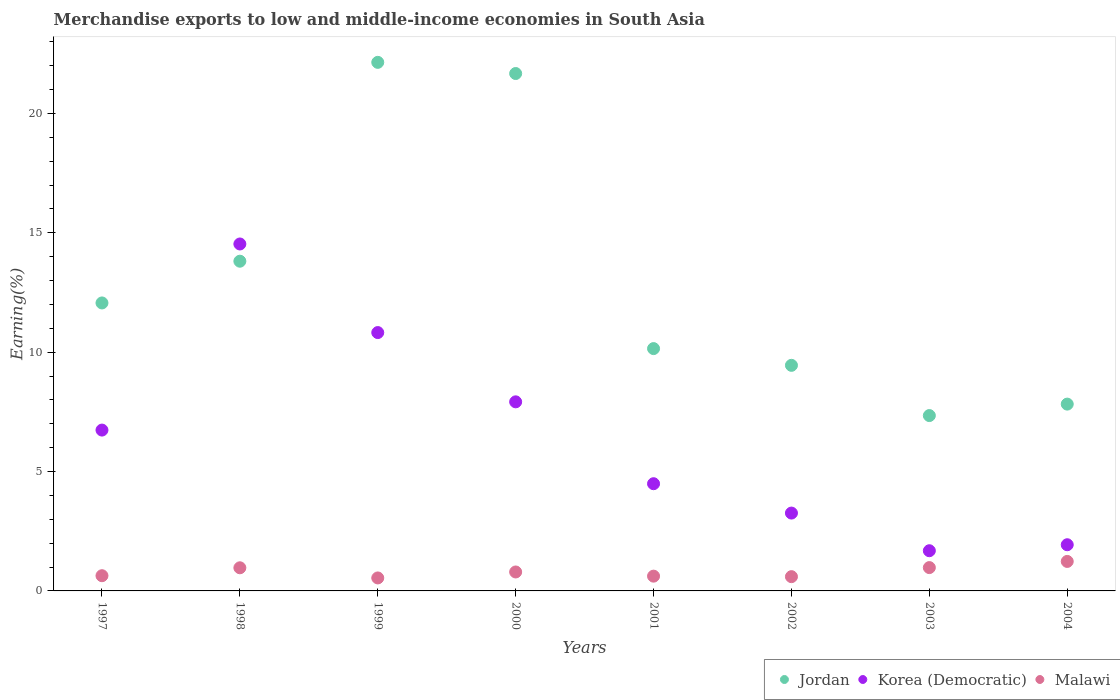How many different coloured dotlines are there?
Offer a terse response. 3. Is the number of dotlines equal to the number of legend labels?
Provide a succinct answer. Yes. What is the percentage of amount earned from merchandise exports in Korea (Democratic) in 1998?
Make the answer very short. 14.53. Across all years, what is the maximum percentage of amount earned from merchandise exports in Jordan?
Give a very brief answer. 22.14. Across all years, what is the minimum percentage of amount earned from merchandise exports in Korea (Democratic)?
Your answer should be very brief. 1.68. In which year was the percentage of amount earned from merchandise exports in Jordan maximum?
Make the answer very short. 1999. What is the total percentage of amount earned from merchandise exports in Malawi in the graph?
Your answer should be very brief. 6.37. What is the difference between the percentage of amount earned from merchandise exports in Jordan in 1999 and that in 2004?
Offer a very short reply. 14.31. What is the difference between the percentage of amount earned from merchandise exports in Korea (Democratic) in 2002 and the percentage of amount earned from merchandise exports in Jordan in 1999?
Your answer should be very brief. -18.88. What is the average percentage of amount earned from merchandise exports in Malawi per year?
Make the answer very short. 0.8. In the year 2004, what is the difference between the percentage of amount earned from merchandise exports in Korea (Democratic) and percentage of amount earned from merchandise exports in Jordan?
Keep it short and to the point. -5.89. In how many years, is the percentage of amount earned from merchandise exports in Korea (Democratic) greater than 9 %?
Your answer should be compact. 2. What is the ratio of the percentage of amount earned from merchandise exports in Jordan in 2002 to that in 2003?
Ensure brevity in your answer.  1.29. Is the percentage of amount earned from merchandise exports in Korea (Democratic) in 1999 less than that in 2002?
Your answer should be very brief. No. What is the difference between the highest and the second highest percentage of amount earned from merchandise exports in Jordan?
Your response must be concise. 0.47. What is the difference between the highest and the lowest percentage of amount earned from merchandise exports in Jordan?
Offer a terse response. 14.79. In how many years, is the percentage of amount earned from merchandise exports in Malawi greater than the average percentage of amount earned from merchandise exports in Malawi taken over all years?
Provide a succinct answer. 3. Does the percentage of amount earned from merchandise exports in Korea (Democratic) monotonically increase over the years?
Your answer should be very brief. No. Is the percentage of amount earned from merchandise exports in Jordan strictly less than the percentage of amount earned from merchandise exports in Korea (Democratic) over the years?
Your response must be concise. No. How many dotlines are there?
Keep it short and to the point. 3. What is the difference between two consecutive major ticks on the Y-axis?
Provide a succinct answer. 5. Are the values on the major ticks of Y-axis written in scientific E-notation?
Ensure brevity in your answer.  No. Where does the legend appear in the graph?
Your response must be concise. Bottom right. What is the title of the graph?
Your answer should be compact. Merchandise exports to low and middle-income economies in South Asia. What is the label or title of the Y-axis?
Your response must be concise. Earning(%). What is the Earning(%) of Jordan in 1997?
Offer a terse response. 12.06. What is the Earning(%) of Korea (Democratic) in 1997?
Give a very brief answer. 6.74. What is the Earning(%) of Malawi in 1997?
Offer a terse response. 0.64. What is the Earning(%) of Jordan in 1998?
Your answer should be very brief. 13.81. What is the Earning(%) of Korea (Democratic) in 1998?
Ensure brevity in your answer.  14.53. What is the Earning(%) of Malawi in 1998?
Provide a short and direct response. 0.97. What is the Earning(%) in Jordan in 1999?
Offer a terse response. 22.14. What is the Earning(%) of Korea (Democratic) in 1999?
Provide a succinct answer. 10.82. What is the Earning(%) in Malawi in 1999?
Give a very brief answer. 0.54. What is the Earning(%) in Jordan in 2000?
Provide a succinct answer. 21.67. What is the Earning(%) of Korea (Democratic) in 2000?
Provide a short and direct response. 7.92. What is the Earning(%) in Malawi in 2000?
Offer a very short reply. 0.79. What is the Earning(%) of Jordan in 2001?
Offer a very short reply. 10.15. What is the Earning(%) of Korea (Democratic) in 2001?
Ensure brevity in your answer.  4.49. What is the Earning(%) in Malawi in 2001?
Your answer should be compact. 0.62. What is the Earning(%) in Jordan in 2002?
Ensure brevity in your answer.  9.45. What is the Earning(%) in Korea (Democratic) in 2002?
Ensure brevity in your answer.  3.26. What is the Earning(%) of Malawi in 2002?
Offer a terse response. 0.6. What is the Earning(%) of Jordan in 2003?
Provide a short and direct response. 7.34. What is the Earning(%) of Korea (Democratic) in 2003?
Your response must be concise. 1.68. What is the Earning(%) of Malawi in 2003?
Provide a succinct answer. 0.98. What is the Earning(%) in Jordan in 2004?
Offer a very short reply. 7.82. What is the Earning(%) in Korea (Democratic) in 2004?
Give a very brief answer. 1.93. What is the Earning(%) in Malawi in 2004?
Give a very brief answer. 1.23. Across all years, what is the maximum Earning(%) in Jordan?
Keep it short and to the point. 22.14. Across all years, what is the maximum Earning(%) in Korea (Democratic)?
Provide a short and direct response. 14.53. Across all years, what is the maximum Earning(%) of Malawi?
Keep it short and to the point. 1.23. Across all years, what is the minimum Earning(%) of Jordan?
Offer a very short reply. 7.34. Across all years, what is the minimum Earning(%) in Korea (Democratic)?
Offer a very short reply. 1.68. Across all years, what is the minimum Earning(%) of Malawi?
Give a very brief answer. 0.54. What is the total Earning(%) of Jordan in the graph?
Provide a short and direct response. 104.44. What is the total Earning(%) in Korea (Democratic) in the graph?
Make the answer very short. 51.37. What is the total Earning(%) of Malawi in the graph?
Your response must be concise. 6.37. What is the difference between the Earning(%) in Jordan in 1997 and that in 1998?
Ensure brevity in your answer.  -1.75. What is the difference between the Earning(%) of Korea (Democratic) in 1997 and that in 1998?
Provide a succinct answer. -7.79. What is the difference between the Earning(%) in Malawi in 1997 and that in 1998?
Offer a very short reply. -0.33. What is the difference between the Earning(%) of Jordan in 1997 and that in 1999?
Your answer should be very brief. -10.08. What is the difference between the Earning(%) of Korea (Democratic) in 1997 and that in 1999?
Provide a short and direct response. -4.08. What is the difference between the Earning(%) in Malawi in 1997 and that in 1999?
Give a very brief answer. 0.09. What is the difference between the Earning(%) in Jordan in 1997 and that in 2000?
Keep it short and to the point. -9.61. What is the difference between the Earning(%) in Korea (Democratic) in 1997 and that in 2000?
Ensure brevity in your answer.  -1.18. What is the difference between the Earning(%) of Malawi in 1997 and that in 2000?
Your response must be concise. -0.16. What is the difference between the Earning(%) in Jordan in 1997 and that in 2001?
Make the answer very short. 1.91. What is the difference between the Earning(%) of Korea (Democratic) in 1997 and that in 2001?
Provide a succinct answer. 2.25. What is the difference between the Earning(%) in Malawi in 1997 and that in 2001?
Your answer should be very brief. 0.02. What is the difference between the Earning(%) of Jordan in 1997 and that in 2002?
Make the answer very short. 2.61. What is the difference between the Earning(%) of Korea (Democratic) in 1997 and that in 2002?
Your answer should be compact. 3.48. What is the difference between the Earning(%) in Malawi in 1997 and that in 2002?
Give a very brief answer. 0.04. What is the difference between the Earning(%) of Jordan in 1997 and that in 2003?
Give a very brief answer. 4.72. What is the difference between the Earning(%) in Korea (Democratic) in 1997 and that in 2003?
Your answer should be very brief. 5.05. What is the difference between the Earning(%) in Malawi in 1997 and that in 2003?
Offer a terse response. -0.34. What is the difference between the Earning(%) of Jordan in 1997 and that in 2004?
Keep it short and to the point. 4.24. What is the difference between the Earning(%) of Korea (Democratic) in 1997 and that in 2004?
Your answer should be very brief. 4.8. What is the difference between the Earning(%) in Malawi in 1997 and that in 2004?
Your answer should be very brief. -0.6. What is the difference between the Earning(%) of Jordan in 1998 and that in 1999?
Provide a short and direct response. -8.33. What is the difference between the Earning(%) in Korea (Democratic) in 1998 and that in 1999?
Your answer should be very brief. 3.71. What is the difference between the Earning(%) of Malawi in 1998 and that in 1999?
Your response must be concise. 0.43. What is the difference between the Earning(%) in Jordan in 1998 and that in 2000?
Provide a succinct answer. -7.86. What is the difference between the Earning(%) in Korea (Democratic) in 1998 and that in 2000?
Your answer should be very brief. 6.61. What is the difference between the Earning(%) in Malawi in 1998 and that in 2000?
Keep it short and to the point. 0.18. What is the difference between the Earning(%) of Jordan in 1998 and that in 2001?
Your answer should be compact. 3.66. What is the difference between the Earning(%) in Korea (Democratic) in 1998 and that in 2001?
Offer a very short reply. 10.04. What is the difference between the Earning(%) of Malawi in 1998 and that in 2001?
Ensure brevity in your answer.  0.35. What is the difference between the Earning(%) of Jordan in 1998 and that in 2002?
Your answer should be compact. 4.36. What is the difference between the Earning(%) of Korea (Democratic) in 1998 and that in 2002?
Offer a terse response. 11.27. What is the difference between the Earning(%) of Malawi in 1998 and that in 2002?
Your response must be concise. 0.37. What is the difference between the Earning(%) in Jordan in 1998 and that in 2003?
Offer a terse response. 6.46. What is the difference between the Earning(%) of Korea (Democratic) in 1998 and that in 2003?
Ensure brevity in your answer.  12.85. What is the difference between the Earning(%) in Malawi in 1998 and that in 2003?
Keep it short and to the point. -0.01. What is the difference between the Earning(%) in Jordan in 1998 and that in 2004?
Your response must be concise. 5.98. What is the difference between the Earning(%) in Korea (Democratic) in 1998 and that in 2004?
Provide a short and direct response. 12.6. What is the difference between the Earning(%) in Malawi in 1998 and that in 2004?
Give a very brief answer. -0.27. What is the difference between the Earning(%) of Jordan in 1999 and that in 2000?
Offer a very short reply. 0.47. What is the difference between the Earning(%) in Korea (Democratic) in 1999 and that in 2000?
Keep it short and to the point. 2.9. What is the difference between the Earning(%) in Malawi in 1999 and that in 2000?
Provide a short and direct response. -0.25. What is the difference between the Earning(%) of Jordan in 1999 and that in 2001?
Keep it short and to the point. 11.99. What is the difference between the Earning(%) of Korea (Democratic) in 1999 and that in 2001?
Give a very brief answer. 6.33. What is the difference between the Earning(%) of Malawi in 1999 and that in 2001?
Offer a very short reply. -0.08. What is the difference between the Earning(%) in Jordan in 1999 and that in 2002?
Your answer should be compact. 12.69. What is the difference between the Earning(%) of Korea (Democratic) in 1999 and that in 2002?
Ensure brevity in your answer.  7.56. What is the difference between the Earning(%) of Malawi in 1999 and that in 2002?
Give a very brief answer. -0.05. What is the difference between the Earning(%) of Jordan in 1999 and that in 2003?
Provide a short and direct response. 14.79. What is the difference between the Earning(%) in Korea (Democratic) in 1999 and that in 2003?
Make the answer very short. 9.14. What is the difference between the Earning(%) of Malawi in 1999 and that in 2003?
Ensure brevity in your answer.  -0.43. What is the difference between the Earning(%) of Jordan in 1999 and that in 2004?
Give a very brief answer. 14.31. What is the difference between the Earning(%) in Korea (Democratic) in 1999 and that in 2004?
Offer a terse response. 8.89. What is the difference between the Earning(%) of Malawi in 1999 and that in 2004?
Provide a succinct answer. -0.69. What is the difference between the Earning(%) in Jordan in 2000 and that in 2001?
Make the answer very short. 11.52. What is the difference between the Earning(%) of Korea (Democratic) in 2000 and that in 2001?
Your answer should be compact. 3.43. What is the difference between the Earning(%) of Malawi in 2000 and that in 2001?
Keep it short and to the point. 0.17. What is the difference between the Earning(%) of Jordan in 2000 and that in 2002?
Offer a very short reply. 12.22. What is the difference between the Earning(%) in Korea (Democratic) in 2000 and that in 2002?
Make the answer very short. 4.66. What is the difference between the Earning(%) in Malawi in 2000 and that in 2002?
Your answer should be very brief. 0.2. What is the difference between the Earning(%) in Jordan in 2000 and that in 2003?
Your response must be concise. 14.33. What is the difference between the Earning(%) of Korea (Democratic) in 2000 and that in 2003?
Offer a terse response. 6.24. What is the difference between the Earning(%) in Malawi in 2000 and that in 2003?
Provide a short and direct response. -0.18. What is the difference between the Earning(%) of Jordan in 2000 and that in 2004?
Make the answer very short. 13.85. What is the difference between the Earning(%) of Korea (Democratic) in 2000 and that in 2004?
Make the answer very short. 5.98. What is the difference between the Earning(%) in Malawi in 2000 and that in 2004?
Ensure brevity in your answer.  -0.44. What is the difference between the Earning(%) in Jordan in 2001 and that in 2002?
Your answer should be compact. 0.7. What is the difference between the Earning(%) in Korea (Democratic) in 2001 and that in 2002?
Offer a terse response. 1.23. What is the difference between the Earning(%) of Malawi in 2001 and that in 2002?
Give a very brief answer. 0.02. What is the difference between the Earning(%) in Jordan in 2001 and that in 2003?
Offer a very short reply. 2.81. What is the difference between the Earning(%) of Korea (Democratic) in 2001 and that in 2003?
Your answer should be very brief. 2.81. What is the difference between the Earning(%) in Malawi in 2001 and that in 2003?
Your answer should be compact. -0.36. What is the difference between the Earning(%) of Jordan in 2001 and that in 2004?
Provide a short and direct response. 2.33. What is the difference between the Earning(%) in Korea (Democratic) in 2001 and that in 2004?
Give a very brief answer. 2.56. What is the difference between the Earning(%) in Malawi in 2001 and that in 2004?
Your response must be concise. -0.62. What is the difference between the Earning(%) in Jordan in 2002 and that in 2003?
Offer a terse response. 2.1. What is the difference between the Earning(%) in Korea (Democratic) in 2002 and that in 2003?
Provide a succinct answer. 1.58. What is the difference between the Earning(%) of Malawi in 2002 and that in 2003?
Make the answer very short. -0.38. What is the difference between the Earning(%) of Jordan in 2002 and that in 2004?
Make the answer very short. 1.62. What is the difference between the Earning(%) in Korea (Democratic) in 2002 and that in 2004?
Your response must be concise. 1.33. What is the difference between the Earning(%) in Malawi in 2002 and that in 2004?
Your response must be concise. -0.64. What is the difference between the Earning(%) of Jordan in 2003 and that in 2004?
Your answer should be very brief. -0.48. What is the difference between the Earning(%) of Korea (Democratic) in 2003 and that in 2004?
Make the answer very short. -0.25. What is the difference between the Earning(%) of Malawi in 2003 and that in 2004?
Your answer should be compact. -0.26. What is the difference between the Earning(%) of Jordan in 1997 and the Earning(%) of Korea (Democratic) in 1998?
Offer a terse response. -2.47. What is the difference between the Earning(%) in Jordan in 1997 and the Earning(%) in Malawi in 1998?
Make the answer very short. 11.09. What is the difference between the Earning(%) of Korea (Democratic) in 1997 and the Earning(%) of Malawi in 1998?
Give a very brief answer. 5.77. What is the difference between the Earning(%) of Jordan in 1997 and the Earning(%) of Korea (Democratic) in 1999?
Ensure brevity in your answer.  1.24. What is the difference between the Earning(%) in Jordan in 1997 and the Earning(%) in Malawi in 1999?
Ensure brevity in your answer.  11.52. What is the difference between the Earning(%) of Korea (Democratic) in 1997 and the Earning(%) of Malawi in 1999?
Provide a short and direct response. 6.19. What is the difference between the Earning(%) of Jordan in 1997 and the Earning(%) of Korea (Democratic) in 2000?
Offer a terse response. 4.14. What is the difference between the Earning(%) of Jordan in 1997 and the Earning(%) of Malawi in 2000?
Provide a short and direct response. 11.27. What is the difference between the Earning(%) of Korea (Democratic) in 1997 and the Earning(%) of Malawi in 2000?
Provide a short and direct response. 5.94. What is the difference between the Earning(%) of Jordan in 1997 and the Earning(%) of Korea (Democratic) in 2001?
Your answer should be very brief. 7.57. What is the difference between the Earning(%) of Jordan in 1997 and the Earning(%) of Malawi in 2001?
Provide a short and direct response. 11.44. What is the difference between the Earning(%) in Korea (Democratic) in 1997 and the Earning(%) in Malawi in 2001?
Your answer should be very brief. 6.12. What is the difference between the Earning(%) of Jordan in 1997 and the Earning(%) of Korea (Democratic) in 2002?
Make the answer very short. 8.8. What is the difference between the Earning(%) of Jordan in 1997 and the Earning(%) of Malawi in 2002?
Ensure brevity in your answer.  11.46. What is the difference between the Earning(%) of Korea (Democratic) in 1997 and the Earning(%) of Malawi in 2002?
Your answer should be compact. 6.14. What is the difference between the Earning(%) in Jordan in 1997 and the Earning(%) in Korea (Democratic) in 2003?
Your response must be concise. 10.38. What is the difference between the Earning(%) of Jordan in 1997 and the Earning(%) of Malawi in 2003?
Keep it short and to the point. 11.08. What is the difference between the Earning(%) in Korea (Democratic) in 1997 and the Earning(%) in Malawi in 2003?
Your answer should be very brief. 5.76. What is the difference between the Earning(%) in Jordan in 1997 and the Earning(%) in Korea (Democratic) in 2004?
Your response must be concise. 10.13. What is the difference between the Earning(%) of Jordan in 1997 and the Earning(%) of Malawi in 2004?
Make the answer very short. 10.83. What is the difference between the Earning(%) in Korea (Democratic) in 1997 and the Earning(%) in Malawi in 2004?
Offer a very short reply. 5.5. What is the difference between the Earning(%) of Jordan in 1998 and the Earning(%) of Korea (Democratic) in 1999?
Make the answer very short. 2.99. What is the difference between the Earning(%) of Jordan in 1998 and the Earning(%) of Malawi in 1999?
Provide a succinct answer. 13.26. What is the difference between the Earning(%) of Korea (Democratic) in 1998 and the Earning(%) of Malawi in 1999?
Make the answer very short. 13.99. What is the difference between the Earning(%) in Jordan in 1998 and the Earning(%) in Korea (Democratic) in 2000?
Give a very brief answer. 5.89. What is the difference between the Earning(%) of Jordan in 1998 and the Earning(%) of Malawi in 2000?
Give a very brief answer. 13.01. What is the difference between the Earning(%) of Korea (Democratic) in 1998 and the Earning(%) of Malawi in 2000?
Offer a terse response. 13.74. What is the difference between the Earning(%) of Jordan in 1998 and the Earning(%) of Korea (Democratic) in 2001?
Keep it short and to the point. 9.32. What is the difference between the Earning(%) of Jordan in 1998 and the Earning(%) of Malawi in 2001?
Your response must be concise. 13.19. What is the difference between the Earning(%) in Korea (Democratic) in 1998 and the Earning(%) in Malawi in 2001?
Keep it short and to the point. 13.91. What is the difference between the Earning(%) in Jordan in 1998 and the Earning(%) in Korea (Democratic) in 2002?
Make the answer very short. 10.55. What is the difference between the Earning(%) of Jordan in 1998 and the Earning(%) of Malawi in 2002?
Provide a short and direct response. 13.21. What is the difference between the Earning(%) of Korea (Democratic) in 1998 and the Earning(%) of Malawi in 2002?
Offer a very short reply. 13.93. What is the difference between the Earning(%) in Jordan in 1998 and the Earning(%) in Korea (Democratic) in 2003?
Make the answer very short. 12.13. What is the difference between the Earning(%) in Jordan in 1998 and the Earning(%) in Malawi in 2003?
Your answer should be very brief. 12.83. What is the difference between the Earning(%) in Korea (Democratic) in 1998 and the Earning(%) in Malawi in 2003?
Your answer should be compact. 13.55. What is the difference between the Earning(%) of Jordan in 1998 and the Earning(%) of Korea (Democratic) in 2004?
Your answer should be very brief. 11.87. What is the difference between the Earning(%) of Jordan in 1998 and the Earning(%) of Malawi in 2004?
Provide a short and direct response. 12.57. What is the difference between the Earning(%) in Korea (Democratic) in 1998 and the Earning(%) in Malawi in 2004?
Provide a short and direct response. 13.29. What is the difference between the Earning(%) in Jordan in 1999 and the Earning(%) in Korea (Democratic) in 2000?
Keep it short and to the point. 14.22. What is the difference between the Earning(%) of Jordan in 1999 and the Earning(%) of Malawi in 2000?
Ensure brevity in your answer.  21.34. What is the difference between the Earning(%) in Korea (Democratic) in 1999 and the Earning(%) in Malawi in 2000?
Your response must be concise. 10.03. What is the difference between the Earning(%) of Jordan in 1999 and the Earning(%) of Korea (Democratic) in 2001?
Provide a short and direct response. 17.65. What is the difference between the Earning(%) in Jordan in 1999 and the Earning(%) in Malawi in 2001?
Ensure brevity in your answer.  21.52. What is the difference between the Earning(%) in Korea (Democratic) in 1999 and the Earning(%) in Malawi in 2001?
Keep it short and to the point. 10.2. What is the difference between the Earning(%) in Jordan in 1999 and the Earning(%) in Korea (Democratic) in 2002?
Provide a succinct answer. 18.88. What is the difference between the Earning(%) in Jordan in 1999 and the Earning(%) in Malawi in 2002?
Provide a succinct answer. 21.54. What is the difference between the Earning(%) of Korea (Democratic) in 1999 and the Earning(%) of Malawi in 2002?
Ensure brevity in your answer.  10.22. What is the difference between the Earning(%) of Jordan in 1999 and the Earning(%) of Korea (Democratic) in 2003?
Make the answer very short. 20.45. What is the difference between the Earning(%) in Jordan in 1999 and the Earning(%) in Malawi in 2003?
Keep it short and to the point. 21.16. What is the difference between the Earning(%) in Korea (Democratic) in 1999 and the Earning(%) in Malawi in 2003?
Provide a succinct answer. 9.84. What is the difference between the Earning(%) of Jordan in 1999 and the Earning(%) of Korea (Democratic) in 2004?
Make the answer very short. 20.2. What is the difference between the Earning(%) of Jordan in 1999 and the Earning(%) of Malawi in 2004?
Your answer should be compact. 20.9. What is the difference between the Earning(%) in Korea (Democratic) in 1999 and the Earning(%) in Malawi in 2004?
Provide a succinct answer. 9.58. What is the difference between the Earning(%) of Jordan in 2000 and the Earning(%) of Korea (Democratic) in 2001?
Provide a succinct answer. 17.18. What is the difference between the Earning(%) of Jordan in 2000 and the Earning(%) of Malawi in 2001?
Provide a short and direct response. 21.05. What is the difference between the Earning(%) of Jordan in 2000 and the Earning(%) of Korea (Democratic) in 2002?
Your response must be concise. 18.41. What is the difference between the Earning(%) in Jordan in 2000 and the Earning(%) in Malawi in 2002?
Make the answer very short. 21.07. What is the difference between the Earning(%) of Korea (Democratic) in 2000 and the Earning(%) of Malawi in 2002?
Give a very brief answer. 7.32. What is the difference between the Earning(%) of Jordan in 2000 and the Earning(%) of Korea (Democratic) in 2003?
Provide a succinct answer. 19.99. What is the difference between the Earning(%) in Jordan in 2000 and the Earning(%) in Malawi in 2003?
Your response must be concise. 20.69. What is the difference between the Earning(%) in Korea (Democratic) in 2000 and the Earning(%) in Malawi in 2003?
Give a very brief answer. 6.94. What is the difference between the Earning(%) in Jordan in 2000 and the Earning(%) in Korea (Democratic) in 2004?
Your answer should be very brief. 19.73. What is the difference between the Earning(%) in Jordan in 2000 and the Earning(%) in Malawi in 2004?
Offer a very short reply. 20.43. What is the difference between the Earning(%) of Korea (Democratic) in 2000 and the Earning(%) of Malawi in 2004?
Keep it short and to the point. 6.68. What is the difference between the Earning(%) in Jordan in 2001 and the Earning(%) in Korea (Democratic) in 2002?
Your answer should be very brief. 6.89. What is the difference between the Earning(%) of Jordan in 2001 and the Earning(%) of Malawi in 2002?
Your answer should be compact. 9.55. What is the difference between the Earning(%) of Korea (Democratic) in 2001 and the Earning(%) of Malawi in 2002?
Provide a short and direct response. 3.89. What is the difference between the Earning(%) of Jordan in 2001 and the Earning(%) of Korea (Democratic) in 2003?
Offer a terse response. 8.47. What is the difference between the Earning(%) in Jordan in 2001 and the Earning(%) in Malawi in 2003?
Offer a very short reply. 9.17. What is the difference between the Earning(%) of Korea (Democratic) in 2001 and the Earning(%) of Malawi in 2003?
Provide a succinct answer. 3.51. What is the difference between the Earning(%) of Jordan in 2001 and the Earning(%) of Korea (Democratic) in 2004?
Your answer should be very brief. 8.21. What is the difference between the Earning(%) in Jordan in 2001 and the Earning(%) in Malawi in 2004?
Your answer should be very brief. 8.91. What is the difference between the Earning(%) in Korea (Democratic) in 2001 and the Earning(%) in Malawi in 2004?
Your answer should be compact. 3.25. What is the difference between the Earning(%) of Jordan in 2002 and the Earning(%) of Korea (Democratic) in 2003?
Offer a terse response. 7.76. What is the difference between the Earning(%) in Jordan in 2002 and the Earning(%) in Malawi in 2003?
Keep it short and to the point. 8.47. What is the difference between the Earning(%) of Korea (Democratic) in 2002 and the Earning(%) of Malawi in 2003?
Your answer should be very brief. 2.28. What is the difference between the Earning(%) of Jordan in 2002 and the Earning(%) of Korea (Democratic) in 2004?
Offer a terse response. 7.51. What is the difference between the Earning(%) in Jordan in 2002 and the Earning(%) in Malawi in 2004?
Provide a short and direct response. 8.21. What is the difference between the Earning(%) of Korea (Democratic) in 2002 and the Earning(%) of Malawi in 2004?
Ensure brevity in your answer.  2.03. What is the difference between the Earning(%) of Jordan in 2003 and the Earning(%) of Korea (Democratic) in 2004?
Ensure brevity in your answer.  5.41. What is the difference between the Earning(%) of Jordan in 2003 and the Earning(%) of Malawi in 2004?
Ensure brevity in your answer.  6.11. What is the difference between the Earning(%) in Korea (Democratic) in 2003 and the Earning(%) in Malawi in 2004?
Keep it short and to the point. 0.45. What is the average Earning(%) of Jordan per year?
Ensure brevity in your answer.  13.05. What is the average Earning(%) in Korea (Democratic) per year?
Make the answer very short. 6.42. What is the average Earning(%) in Malawi per year?
Provide a short and direct response. 0.8. In the year 1997, what is the difference between the Earning(%) of Jordan and Earning(%) of Korea (Democratic)?
Offer a very short reply. 5.32. In the year 1997, what is the difference between the Earning(%) in Jordan and Earning(%) in Malawi?
Your answer should be compact. 11.42. In the year 1997, what is the difference between the Earning(%) in Korea (Democratic) and Earning(%) in Malawi?
Your answer should be compact. 6.1. In the year 1998, what is the difference between the Earning(%) in Jordan and Earning(%) in Korea (Democratic)?
Make the answer very short. -0.72. In the year 1998, what is the difference between the Earning(%) in Jordan and Earning(%) in Malawi?
Your answer should be very brief. 12.84. In the year 1998, what is the difference between the Earning(%) of Korea (Democratic) and Earning(%) of Malawi?
Your answer should be very brief. 13.56. In the year 1999, what is the difference between the Earning(%) of Jordan and Earning(%) of Korea (Democratic)?
Make the answer very short. 11.32. In the year 1999, what is the difference between the Earning(%) of Jordan and Earning(%) of Malawi?
Offer a very short reply. 21.59. In the year 1999, what is the difference between the Earning(%) of Korea (Democratic) and Earning(%) of Malawi?
Ensure brevity in your answer.  10.28. In the year 2000, what is the difference between the Earning(%) of Jordan and Earning(%) of Korea (Democratic)?
Keep it short and to the point. 13.75. In the year 2000, what is the difference between the Earning(%) of Jordan and Earning(%) of Malawi?
Provide a short and direct response. 20.88. In the year 2000, what is the difference between the Earning(%) in Korea (Democratic) and Earning(%) in Malawi?
Offer a terse response. 7.13. In the year 2001, what is the difference between the Earning(%) in Jordan and Earning(%) in Korea (Democratic)?
Your response must be concise. 5.66. In the year 2001, what is the difference between the Earning(%) in Jordan and Earning(%) in Malawi?
Make the answer very short. 9.53. In the year 2001, what is the difference between the Earning(%) of Korea (Democratic) and Earning(%) of Malawi?
Provide a succinct answer. 3.87. In the year 2002, what is the difference between the Earning(%) in Jordan and Earning(%) in Korea (Democratic)?
Give a very brief answer. 6.19. In the year 2002, what is the difference between the Earning(%) in Jordan and Earning(%) in Malawi?
Give a very brief answer. 8.85. In the year 2002, what is the difference between the Earning(%) in Korea (Democratic) and Earning(%) in Malawi?
Your answer should be compact. 2.66. In the year 2003, what is the difference between the Earning(%) in Jordan and Earning(%) in Korea (Democratic)?
Give a very brief answer. 5.66. In the year 2003, what is the difference between the Earning(%) of Jordan and Earning(%) of Malawi?
Give a very brief answer. 6.37. In the year 2003, what is the difference between the Earning(%) in Korea (Democratic) and Earning(%) in Malawi?
Your response must be concise. 0.71. In the year 2004, what is the difference between the Earning(%) of Jordan and Earning(%) of Korea (Democratic)?
Offer a very short reply. 5.89. In the year 2004, what is the difference between the Earning(%) in Jordan and Earning(%) in Malawi?
Offer a very short reply. 6.59. In the year 2004, what is the difference between the Earning(%) of Korea (Democratic) and Earning(%) of Malawi?
Ensure brevity in your answer.  0.7. What is the ratio of the Earning(%) of Jordan in 1997 to that in 1998?
Ensure brevity in your answer.  0.87. What is the ratio of the Earning(%) in Korea (Democratic) in 1997 to that in 1998?
Give a very brief answer. 0.46. What is the ratio of the Earning(%) of Malawi in 1997 to that in 1998?
Your answer should be very brief. 0.66. What is the ratio of the Earning(%) in Jordan in 1997 to that in 1999?
Your response must be concise. 0.54. What is the ratio of the Earning(%) of Korea (Democratic) in 1997 to that in 1999?
Offer a very short reply. 0.62. What is the ratio of the Earning(%) of Malawi in 1997 to that in 1999?
Keep it short and to the point. 1.17. What is the ratio of the Earning(%) in Jordan in 1997 to that in 2000?
Provide a short and direct response. 0.56. What is the ratio of the Earning(%) in Korea (Democratic) in 1997 to that in 2000?
Offer a very short reply. 0.85. What is the ratio of the Earning(%) in Malawi in 1997 to that in 2000?
Offer a terse response. 0.8. What is the ratio of the Earning(%) of Jordan in 1997 to that in 2001?
Offer a terse response. 1.19. What is the ratio of the Earning(%) in Korea (Democratic) in 1997 to that in 2001?
Your answer should be compact. 1.5. What is the ratio of the Earning(%) in Malawi in 1997 to that in 2001?
Your answer should be compact. 1.03. What is the ratio of the Earning(%) in Jordan in 1997 to that in 2002?
Your answer should be very brief. 1.28. What is the ratio of the Earning(%) of Korea (Democratic) in 1997 to that in 2002?
Make the answer very short. 2.07. What is the ratio of the Earning(%) of Malawi in 1997 to that in 2002?
Provide a succinct answer. 1.07. What is the ratio of the Earning(%) in Jordan in 1997 to that in 2003?
Make the answer very short. 1.64. What is the ratio of the Earning(%) in Korea (Democratic) in 1997 to that in 2003?
Your answer should be compact. 4. What is the ratio of the Earning(%) in Malawi in 1997 to that in 2003?
Keep it short and to the point. 0.65. What is the ratio of the Earning(%) in Jordan in 1997 to that in 2004?
Provide a succinct answer. 1.54. What is the ratio of the Earning(%) in Korea (Democratic) in 1997 to that in 2004?
Offer a terse response. 3.48. What is the ratio of the Earning(%) in Malawi in 1997 to that in 2004?
Offer a very short reply. 0.52. What is the ratio of the Earning(%) in Jordan in 1998 to that in 1999?
Make the answer very short. 0.62. What is the ratio of the Earning(%) in Korea (Democratic) in 1998 to that in 1999?
Your response must be concise. 1.34. What is the ratio of the Earning(%) of Malawi in 1998 to that in 1999?
Provide a short and direct response. 1.78. What is the ratio of the Earning(%) of Jordan in 1998 to that in 2000?
Your response must be concise. 0.64. What is the ratio of the Earning(%) in Korea (Democratic) in 1998 to that in 2000?
Your response must be concise. 1.83. What is the ratio of the Earning(%) of Malawi in 1998 to that in 2000?
Offer a terse response. 1.22. What is the ratio of the Earning(%) in Jordan in 1998 to that in 2001?
Give a very brief answer. 1.36. What is the ratio of the Earning(%) of Korea (Democratic) in 1998 to that in 2001?
Give a very brief answer. 3.24. What is the ratio of the Earning(%) in Malawi in 1998 to that in 2001?
Offer a very short reply. 1.57. What is the ratio of the Earning(%) of Jordan in 1998 to that in 2002?
Make the answer very short. 1.46. What is the ratio of the Earning(%) of Korea (Democratic) in 1998 to that in 2002?
Make the answer very short. 4.46. What is the ratio of the Earning(%) in Malawi in 1998 to that in 2002?
Provide a short and direct response. 1.62. What is the ratio of the Earning(%) in Jordan in 1998 to that in 2003?
Provide a short and direct response. 1.88. What is the ratio of the Earning(%) in Korea (Democratic) in 1998 to that in 2003?
Offer a terse response. 8.63. What is the ratio of the Earning(%) in Malawi in 1998 to that in 2003?
Give a very brief answer. 0.99. What is the ratio of the Earning(%) in Jordan in 1998 to that in 2004?
Give a very brief answer. 1.76. What is the ratio of the Earning(%) in Korea (Democratic) in 1998 to that in 2004?
Keep it short and to the point. 7.51. What is the ratio of the Earning(%) in Malawi in 1998 to that in 2004?
Offer a very short reply. 0.78. What is the ratio of the Earning(%) of Jordan in 1999 to that in 2000?
Make the answer very short. 1.02. What is the ratio of the Earning(%) in Korea (Democratic) in 1999 to that in 2000?
Your answer should be very brief. 1.37. What is the ratio of the Earning(%) of Malawi in 1999 to that in 2000?
Provide a succinct answer. 0.68. What is the ratio of the Earning(%) in Jordan in 1999 to that in 2001?
Your answer should be very brief. 2.18. What is the ratio of the Earning(%) of Korea (Democratic) in 1999 to that in 2001?
Offer a terse response. 2.41. What is the ratio of the Earning(%) in Malawi in 1999 to that in 2001?
Provide a succinct answer. 0.88. What is the ratio of the Earning(%) in Jordan in 1999 to that in 2002?
Ensure brevity in your answer.  2.34. What is the ratio of the Earning(%) of Korea (Democratic) in 1999 to that in 2002?
Offer a terse response. 3.32. What is the ratio of the Earning(%) in Malawi in 1999 to that in 2002?
Offer a terse response. 0.91. What is the ratio of the Earning(%) of Jordan in 1999 to that in 2003?
Your answer should be very brief. 3.01. What is the ratio of the Earning(%) in Korea (Democratic) in 1999 to that in 2003?
Your answer should be compact. 6.43. What is the ratio of the Earning(%) of Malawi in 1999 to that in 2003?
Your answer should be very brief. 0.56. What is the ratio of the Earning(%) in Jordan in 1999 to that in 2004?
Make the answer very short. 2.83. What is the ratio of the Earning(%) of Korea (Democratic) in 1999 to that in 2004?
Offer a terse response. 5.59. What is the ratio of the Earning(%) in Malawi in 1999 to that in 2004?
Your answer should be very brief. 0.44. What is the ratio of the Earning(%) in Jordan in 2000 to that in 2001?
Provide a succinct answer. 2.14. What is the ratio of the Earning(%) in Korea (Democratic) in 2000 to that in 2001?
Make the answer very short. 1.76. What is the ratio of the Earning(%) of Malawi in 2000 to that in 2001?
Offer a terse response. 1.28. What is the ratio of the Earning(%) in Jordan in 2000 to that in 2002?
Your answer should be compact. 2.29. What is the ratio of the Earning(%) of Korea (Democratic) in 2000 to that in 2002?
Your answer should be compact. 2.43. What is the ratio of the Earning(%) in Malawi in 2000 to that in 2002?
Your response must be concise. 1.33. What is the ratio of the Earning(%) of Jordan in 2000 to that in 2003?
Provide a succinct answer. 2.95. What is the ratio of the Earning(%) in Korea (Democratic) in 2000 to that in 2003?
Make the answer very short. 4.7. What is the ratio of the Earning(%) of Malawi in 2000 to that in 2003?
Provide a succinct answer. 0.81. What is the ratio of the Earning(%) in Jordan in 2000 to that in 2004?
Offer a very short reply. 2.77. What is the ratio of the Earning(%) of Korea (Democratic) in 2000 to that in 2004?
Give a very brief answer. 4.09. What is the ratio of the Earning(%) in Malawi in 2000 to that in 2004?
Offer a terse response. 0.64. What is the ratio of the Earning(%) in Jordan in 2001 to that in 2002?
Your answer should be compact. 1.07. What is the ratio of the Earning(%) in Korea (Democratic) in 2001 to that in 2002?
Your response must be concise. 1.38. What is the ratio of the Earning(%) in Malawi in 2001 to that in 2002?
Keep it short and to the point. 1.04. What is the ratio of the Earning(%) of Jordan in 2001 to that in 2003?
Provide a short and direct response. 1.38. What is the ratio of the Earning(%) of Korea (Democratic) in 2001 to that in 2003?
Offer a terse response. 2.67. What is the ratio of the Earning(%) in Malawi in 2001 to that in 2003?
Offer a very short reply. 0.63. What is the ratio of the Earning(%) in Jordan in 2001 to that in 2004?
Provide a short and direct response. 1.3. What is the ratio of the Earning(%) of Korea (Democratic) in 2001 to that in 2004?
Provide a succinct answer. 2.32. What is the ratio of the Earning(%) of Malawi in 2001 to that in 2004?
Your answer should be compact. 0.5. What is the ratio of the Earning(%) of Jordan in 2002 to that in 2003?
Keep it short and to the point. 1.29. What is the ratio of the Earning(%) in Korea (Democratic) in 2002 to that in 2003?
Offer a very short reply. 1.94. What is the ratio of the Earning(%) of Malawi in 2002 to that in 2003?
Your answer should be very brief. 0.61. What is the ratio of the Earning(%) in Jordan in 2002 to that in 2004?
Make the answer very short. 1.21. What is the ratio of the Earning(%) in Korea (Democratic) in 2002 to that in 2004?
Offer a very short reply. 1.69. What is the ratio of the Earning(%) of Malawi in 2002 to that in 2004?
Your response must be concise. 0.48. What is the ratio of the Earning(%) in Jordan in 2003 to that in 2004?
Provide a succinct answer. 0.94. What is the ratio of the Earning(%) of Korea (Democratic) in 2003 to that in 2004?
Keep it short and to the point. 0.87. What is the ratio of the Earning(%) in Malawi in 2003 to that in 2004?
Your answer should be compact. 0.79. What is the difference between the highest and the second highest Earning(%) in Jordan?
Your response must be concise. 0.47. What is the difference between the highest and the second highest Earning(%) in Korea (Democratic)?
Offer a very short reply. 3.71. What is the difference between the highest and the second highest Earning(%) of Malawi?
Keep it short and to the point. 0.26. What is the difference between the highest and the lowest Earning(%) of Jordan?
Your response must be concise. 14.79. What is the difference between the highest and the lowest Earning(%) in Korea (Democratic)?
Keep it short and to the point. 12.85. What is the difference between the highest and the lowest Earning(%) of Malawi?
Keep it short and to the point. 0.69. 